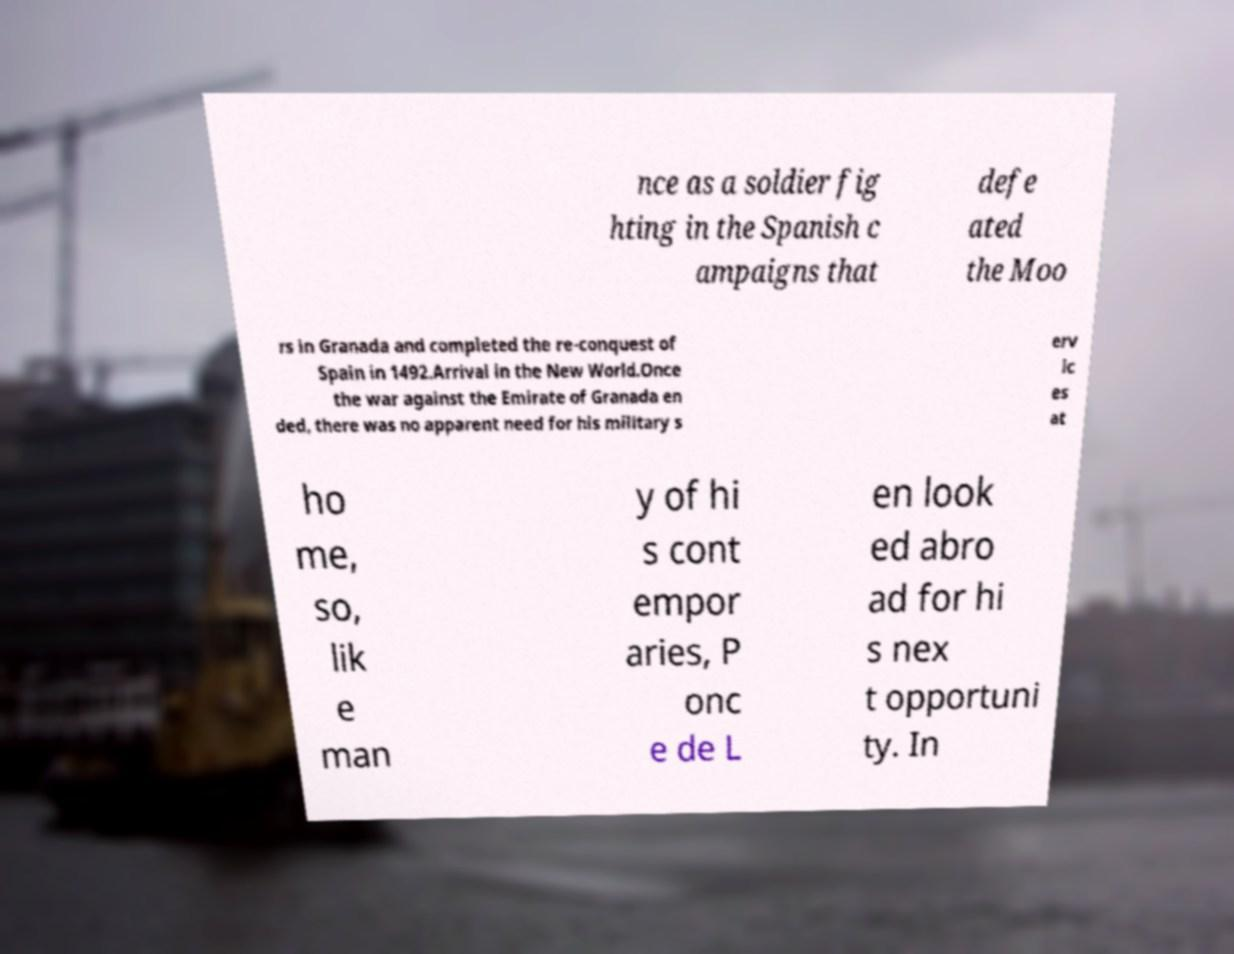There's text embedded in this image that I need extracted. Can you transcribe it verbatim? nce as a soldier fig hting in the Spanish c ampaigns that defe ated the Moo rs in Granada and completed the re-conquest of Spain in 1492.Arrival in the New World.Once the war against the Emirate of Granada en ded, there was no apparent need for his military s erv ic es at ho me, so, lik e man y of hi s cont empor aries, P onc e de L en look ed abro ad for hi s nex t opportuni ty. In 